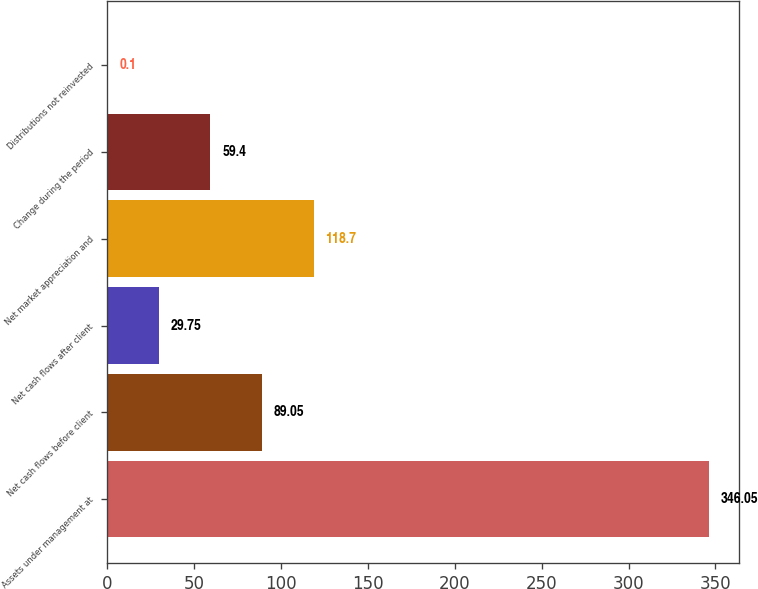Convert chart to OTSL. <chart><loc_0><loc_0><loc_500><loc_500><bar_chart><fcel>Assets under management at<fcel>Net cash flows before client<fcel>Net cash flows after client<fcel>Net market appreciation and<fcel>Change during the period<fcel>Distributions not reinvested<nl><fcel>346.05<fcel>89.05<fcel>29.75<fcel>118.7<fcel>59.4<fcel>0.1<nl></chart> 